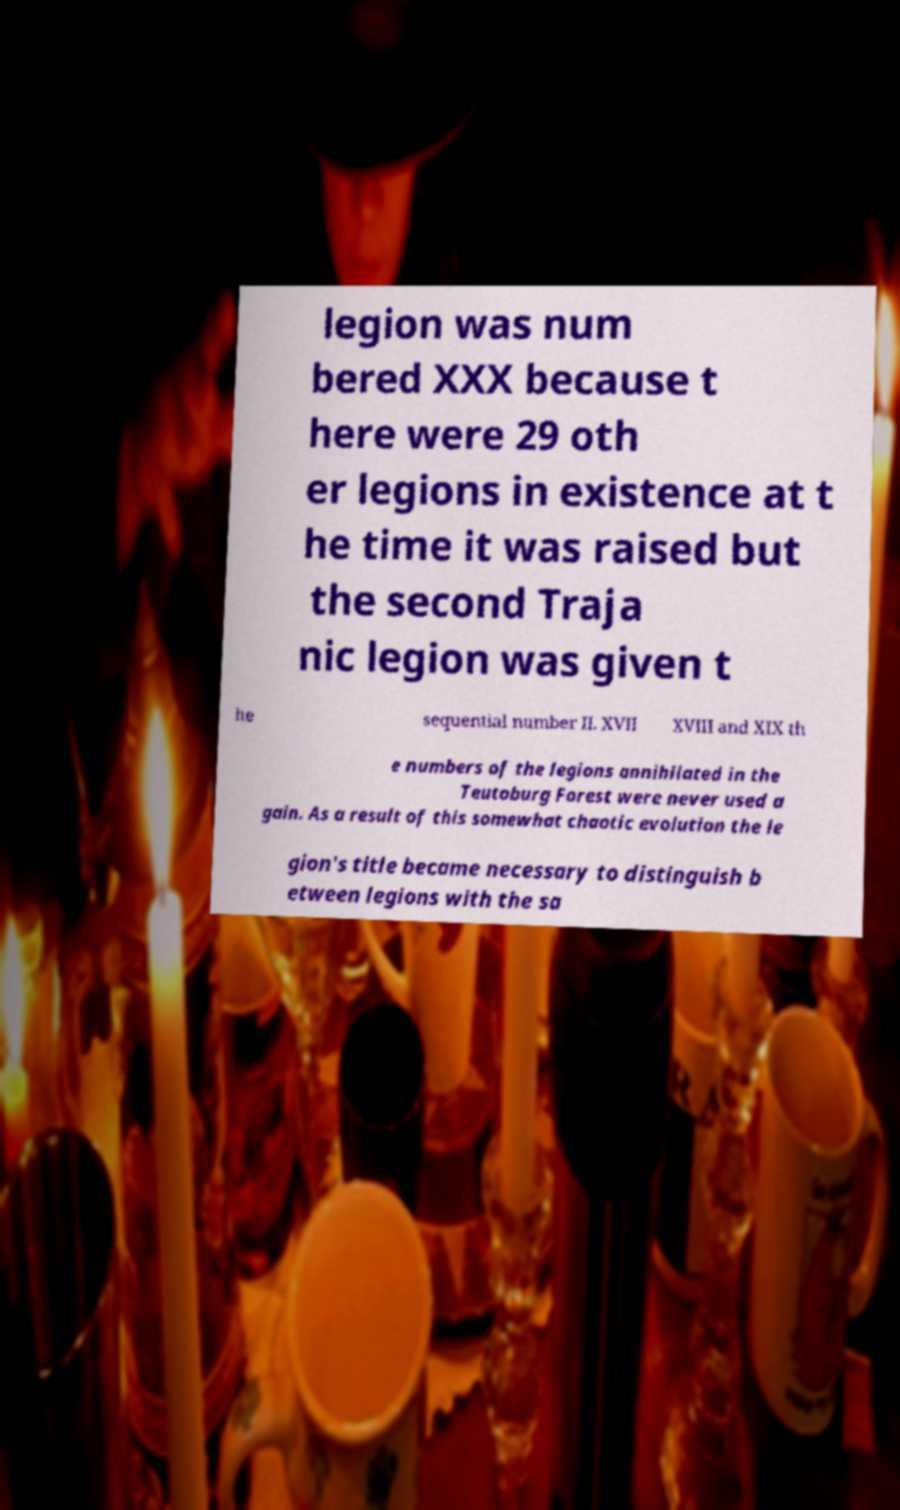Could you extract and type out the text from this image? legion was num bered XXX because t here were 29 oth er legions in existence at t he time it was raised but the second Traja nic legion was given t he sequential number II. XVII XVIII and XIX th e numbers of the legions annihilated in the Teutoburg Forest were never used a gain. As a result of this somewhat chaotic evolution the le gion's title became necessary to distinguish b etween legions with the sa 